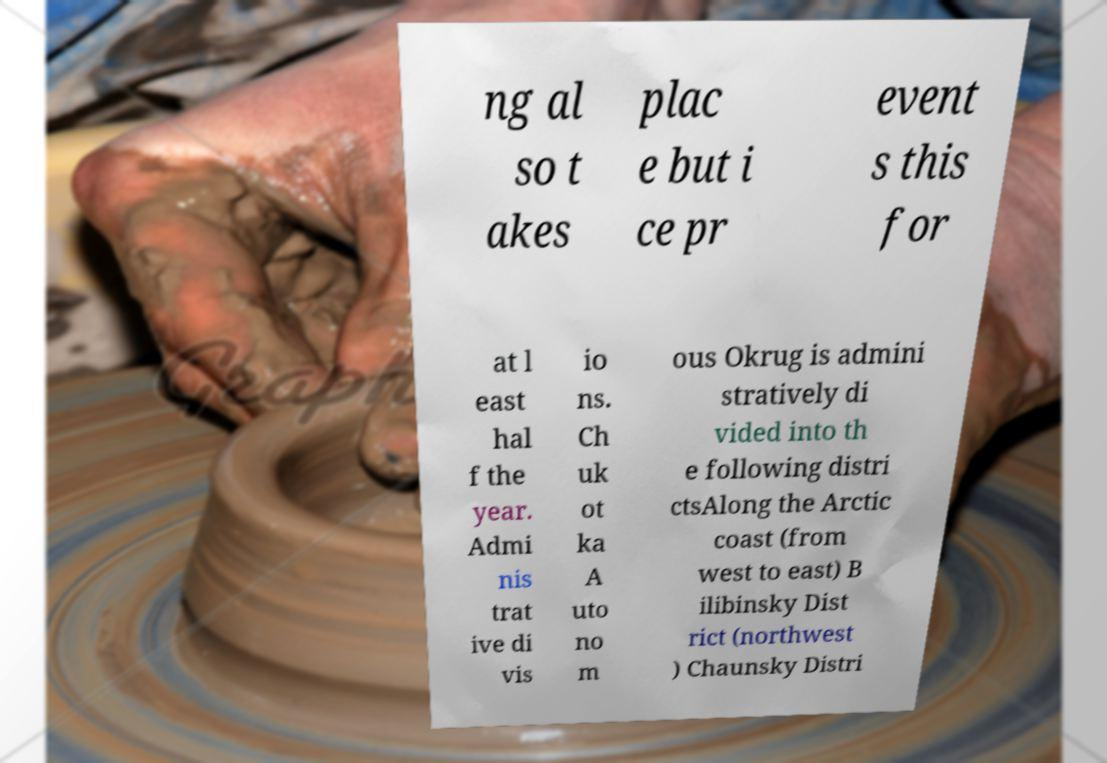Could you assist in decoding the text presented in this image and type it out clearly? ng al so t akes plac e but i ce pr event s this for at l east hal f the year. Admi nis trat ive di vis io ns. Ch uk ot ka A uto no m ous Okrug is admini stratively di vided into th e following distri ctsAlong the Arctic coast (from west to east) B ilibinsky Dist rict (northwest ) Chaunsky Distri 